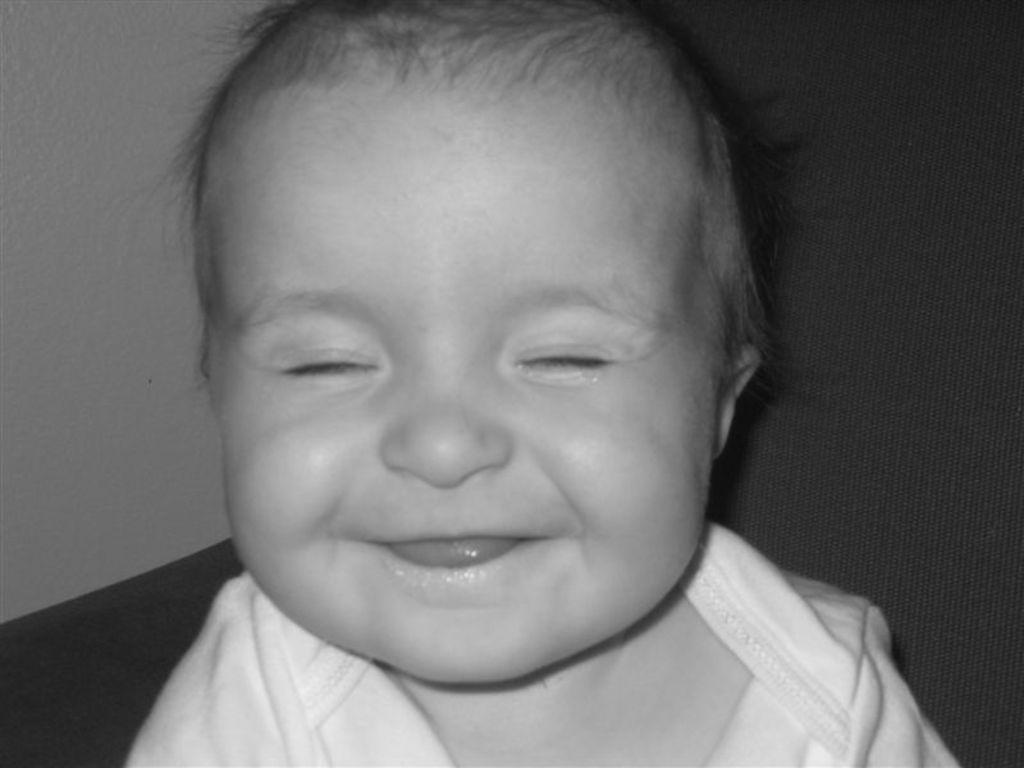Can you describe this image briefly? This is a black and white image and here we can see a kid on the couch and in the background, there is a wall. 